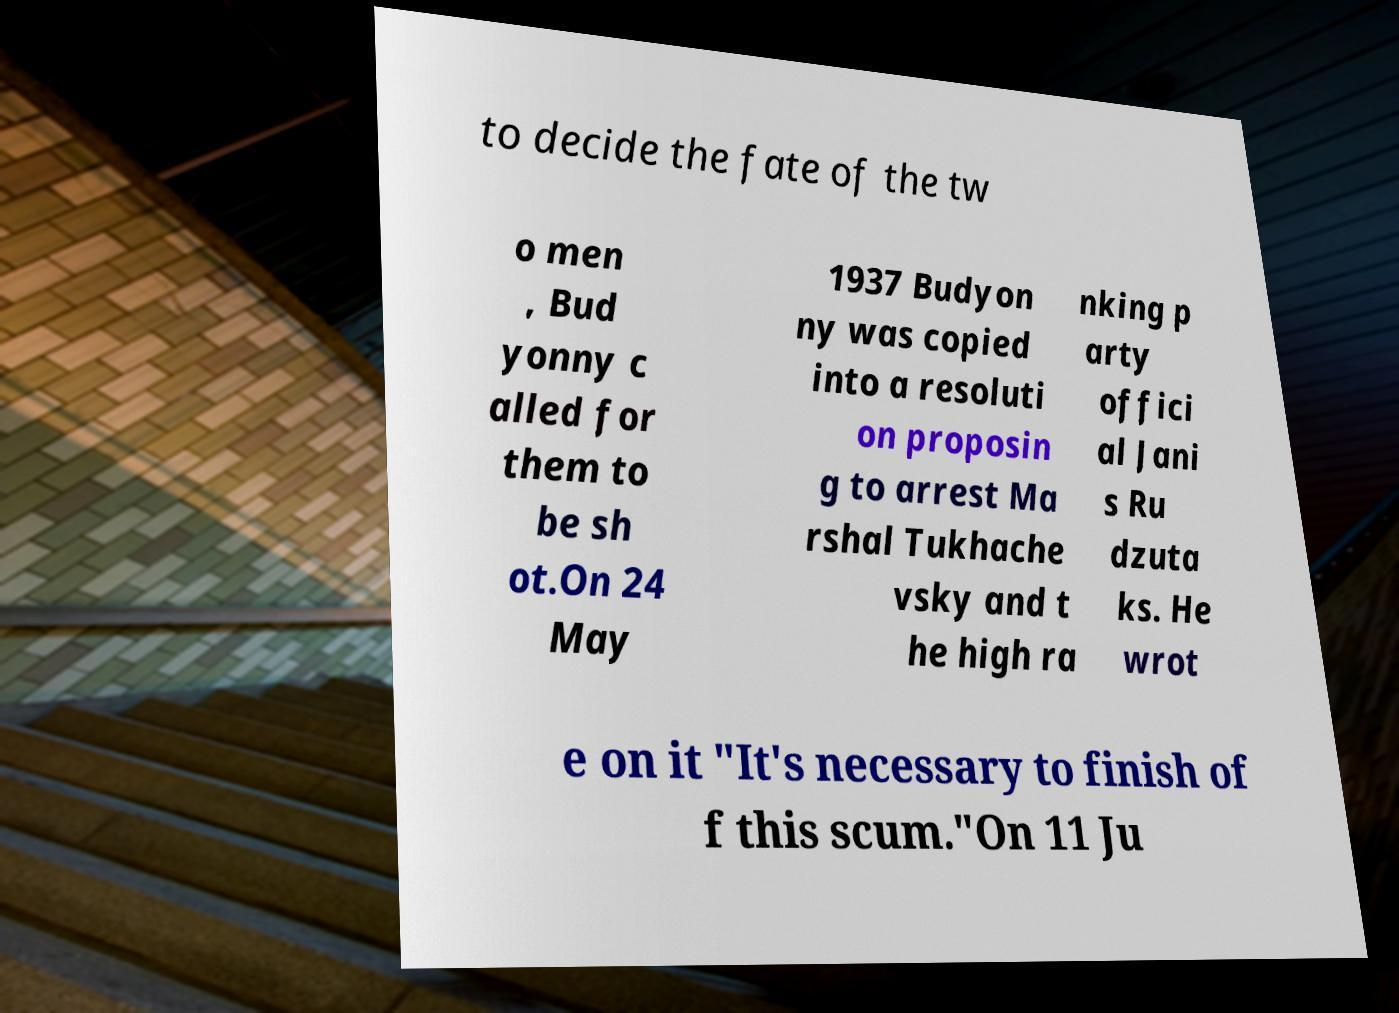Can you accurately transcribe the text from the provided image for me? to decide the fate of the tw o men , Bud yonny c alled for them to be sh ot.On 24 May 1937 Budyon ny was copied into a resoluti on proposin g to arrest Ma rshal Tukhache vsky and t he high ra nking p arty offici al Jani s Ru dzuta ks. He wrot e on it "It's necessary to finish of f this scum."On 11 Ju 